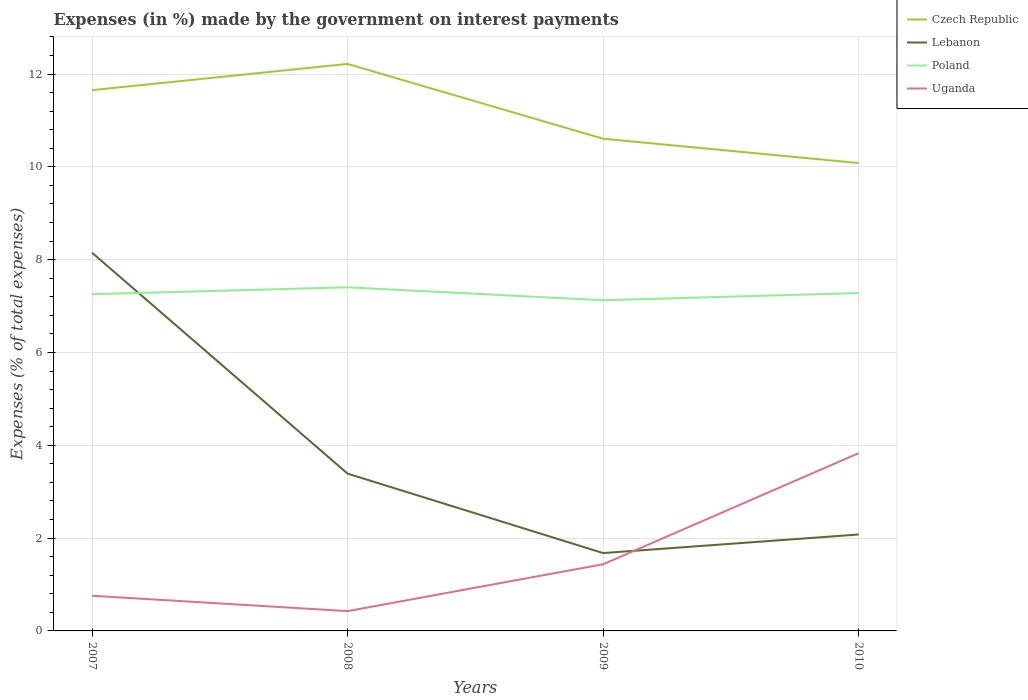How many different coloured lines are there?
Provide a short and direct response. 4. Across all years, what is the maximum percentage of expenses made by the government on interest payments in Poland?
Provide a succinct answer. 7.13. In which year was the percentage of expenses made by the government on interest payments in Uganda maximum?
Offer a very short reply. 2008. What is the total percentage of expenses made by the government on interest payments in Czech Republic in the graph?
Give a very brief answer. 1.05. What is the difference between the highest and the second highest percentage of expenses made by the government on interest payments in Lebanon?
Your response must be concise. 6.47. What is the difference between the highest and the lowest percentage of expenses made by the government on interest payments in Uganda?
Your response must be concise. 1. How many lines are there?
Make the answer very short. 4. Are the values on the major ticks of Y-axis written in scientific E-notation?
Provide a succinct answer. No. Does the graph contain any zero values?
Offer a terse response. No. Does the graph contain grids?
Your response must be concise. Yes. Where does the legend appear in the graph?
Offer a terse response. Top right. How many legend labels are there?
Make the answer very short. 4. What is the title of the graph?
Keep it short and to the point. Expenses (in %) made by the government on interest payments. Does "Portugal" appear as one of the legend labels in the graph?
Your answer should be compact. No. What is the label or title of the Y-axis?
Your answer should be compact. Expenses (% of total expenses). What is the Expenses (% of total expenses) in Czech Republic in 2007?
Your answer should be compact. 11.65. What is the Expenses (% of total expenses) in Lebanon in 2007?
Provide a succinct answer. 8.15. What is the Expenses (% of total expenses) in Poland in 2007?
Your answer should be very brief. 7.26. What is the Expenses (% of total expenses) of Uganda in 2007?
Your response must be concise. 0.76. What is the Expenses (% of total expenses) of Czech Republic in 2008?
Offer a very short reply. 12.22. What is the Expenses (% of total expenses) of Lebanon in 2008?
Keep it short and to the point. 3.39. What is the Expenses (% of total expenses) in Poland in 2008?
Give a very brief answer. 7.4. What is the Expenses (% of total expenses) in Uganda in 2008?
Give a very brief answer. 0.43. What is the Expenses (% of total expenses) in Czech Republic in 2009?
Keep it short and to the point. 10.61. What is the Expenses (% of total expenses) of Lebanon in 2009?
Give a very brief answer. 1.68. What is the Expenses (% of total expenses) of Poland in 2009?
Offer a very short reply. 7.13. What is the Expenses (% of total expenses) in Uganda in 2009?
Ensure brevity in your answer.  1.44. What is the Expenses (% of total expenses) of Czech Republic in 2010?
Your answer should be compact. 10.08. What is the Expenses (% of total expenses) in Lebanon in 2010?
Offer a very short reply. 2.08. What is the Expenses (% of total expenses) of Poland in 2010?
Provide a short and direct response. 7.28. What is the Expenses (% of total expenses) of Uganda in 2010?
Your response must be concise. 3.83. Across all years, what is the maximum Expenses (% of total expenses) of Czech Republic?
Your answer should be very brief. 12.22. Across all years, what is the maximum Expenses (% of total expenses) in Lebanon?
Make the answer very short. 8.15. Across all years, what is the maximum Expenses (% of total expenses) of Poland?
Provide a short and direct response. 7.4. Across all years, what is the maximum Expenses (% of total expenses) of Uganda?
Make the answer very short. 3.83. Across all years, what is the minimum Expenses (% of total expenses) of Czech Republic?
Keep it short and to the point. 10.08. Across all years, what is the minimum Expenses (% of total expenses) in Lebanon?
Your answer should be compact. 1.68. Across all years, what is the minimum Expenses (% of total expenses) of Poland?
Offer a very short reply. 7.13. Across all years, what is the minimum Expenses (% of total expenses) of Uganda?
Your answer should be compact. 0.43. What is the total Expenses (% of total expenses) in Czech Republic in the graph?
Your answer should be compact. 44.56. What is the total Expenses (% of total expenses) of Lebanon in the graph?
Provide a succinct answer. 15.29. What is the total Expenses (% of total expenses) in Poland in the graph?
Keep it short and to the point. 29.07. What is the total Expenses (% of total expenses) of Uganda in the graph?
Make the answer very short. 6.45. What is the difference between the Expenses (% of total expenses) in Czech Republic in 2007 and that in 2008?
Your answer should be very brief. -0.56. What is the difference between the Expenses (% of total expenses) in Lebanon in 2007 and that in 2008?
Make the answer very short. 4.76. What is the difference between the Expenses (% of total expenses) in Poland in 2007 and that in 2008?
Offer a terse response. -0.15. What is the difference between the Expenses (% of total expenses) of Uganda in 2007 and that in 2008?
Your answer should be very brief. 0.33. What is the difference between the Expenses (% of total expenses) of Czech Republic in 2007 and that in 2009?
Your response must be concise. 1.05. What is the difference between the Expenses (% of total expenses) in Lebanon in 2007 and that in 2009?
Provide a short and direct response. 6.47. What is the difference between the Expenses (% of total expenses) of Poland in 2007 and that in 2009?
Give a very brief answer. 0.13. What is the difference between the Expenses (% of total expenses) in Uganda in 2007 and that in 2009?
Your answer should be very brief. -0.68. What is the difference between the Expenses (% of total expenses) of Czech Republic in 2007 and that in 2010?
Ensure brevity in your answer.  1.57. What is the difference between the Expenses (% of total expenses) in Lebanon in 2007 and that in 2010?
Keep it short and to the point. 6.07. What is the difference between the Expenses (% of total expenses) of Poland in 2007 and that in 2010?
Give a very brief answer. -0.03. What is the difference between the Expenses (% of total expenses) in Uganda in 2007 and that in 2010?
Your answer should be compact. -3.07. What is the difference between the Expenses (% of total expenses) of Czech Republic in 2008 and that in 2009?
Offer a terse response. 1.61. What is the difference between the Expenses (% of total expenses) in Lebanon in 2008 and that in 2009?
Give a very brief answer. 1.71. What is the difference between the Expenses (% of total expenses) of Poland in 2008 and that in 2009?
Make the answer very short. 0.28. What is the difference between the Expenses (% of total expenses) in Uganda in 2008 and that in 2009?
Offer a very short reply. -1.01. What is the difference between the Expenses (% of total expenses) in Czech Republic in 2008 and that in 2010?
Give a very brief answer. 2.14. What is the difference between the Expenses (% of total expenses) in Lebanon in 2008 and that in 2010?
Ensure brevity in your answer.  1.31. What is the difference between the Expenses (% of total expenses) of Poland in 2008 and that in 2010?
Your response must be concise. 0.12. What is the difference between the Expenses (% of total expenses) in Uganda in 2008 and that in 2010?
Make the answer very short. -3.4. What is the difference between the Expenses (% of total expenses) in Czech Republic in 2009 and that in 2010?
Give a very brief answer. 0.52. What is the difference between the Expenses (% of total expenses) of Lebanon in 2009 and that in 2010?
Your answer should be very brief. -0.4. What is the difference between the Expenses (% of total expenses) of Poland in 2009 and that in 2010?
Provide a succinct answer. -0.16. What is the difference between the Expenses (% of total expenses) of Uganda in 2009 and that in 2010?
Offer a very short reply. -2.39. What is the difference between the Expenses (% of total expenses) in Czech Republic in 2007 and the Expenses (% of total expenses) in Lebanon in 2008?
Offer a very short reply. 8.26. What is the difference between the Expenses (% of total expenses) in Czech Republic in 2007 and the Expenses (% of total expenses) in Poland in 2008?
Your response must be concise. 4.25. What is the difference between the Expenses (% of total expenses) of Czech Republic in 2007 and the Expenses (% of total expenses) of Uganda in 2008?
Provide a short and direct response. 11.23. What is the difference between the Expenses (% of total expenses) of Lebanon in 2007 and the Expenses (% of total expenses) of Poland in 2008?
Offer a very short reply. 0.74. What is the difference between the Expenses (% of total expenses) in Lebanon in 2007 and the Expenses (% of total expenses) in Uganda in 2008?
Provide a short and direct response. 7.72. What is the difference between the Expenses (% of total expenses) in Poland in 2007 and the Expenses (% of total expenses) in Uganda in 2008?
Keep it short and to the point. 6.83. What is the difference between the Expenses (% of total expenses) of Czech Republic in 2007 and the Expenses (% of total expenses) of Lebanon in 2009?
Make the answer very short. 9.97. What is the difference between the Expenses (% of total expenses) of Czech Republic in 2007 and the Expenses (% of total expenses) of Poland in 2009?
Offer a very short reply. 4.53. What is the difference between the Expenses (% of total expenses) in Czech Republic in 2007 and the Expenses (% of total expenses) in Uganda in 2009?
Make the answer very short. 10.22. What is the difference between the Expenses (% of total expenses) in Lebanon in 2007 and the Expenses (% of total expenses) in Poland in 2009?
Your answer should be compact. 1.02. What is the difference between the Expenses (% of total expenses) of Lebanon in 2007 and the Expenses (% of total expenses) of Uganda in 2009?
Ensure brevity in your answer.  6.71. What is the difference between the Expenses (% of total expenses) in Poland in 2007 and the Expenses (% of total expenses) in Uganda in 2009?
Make the answer very short. 5.82. What is the difference between the Expenses (% of total expenses) of Czech Republic in 2007 and the Expenses (% of total expenses) of Lebanon in 2010?
Your response must be concise. 9.57. What is the difference between the Expenses (% of total expenses) in Czech Republic in 2007 and the Expenses (% of total expenses) in Poland in 2010?
Offer a very short reply. 4.37. What is the difference between the Expenses (% of total expenses) of Czech Republic in 2007 and the Expenses (% of total expenses) of Uganda in 2010?
Make the answer very short. 7.82. What is the difference between the Expenses (% of total expenses) in Lebanon in 2007 and the Expenses (% of total expenses) in Poland in 2010?
Your response must be concise. 0.87. What is the difference between the Expenses (% of total expenses) in Lebanon in 2007 and the Expenses (% of total expenses) in Uganda in 2010?
Your answer should be very brief. 4.32. What is the difference between the Expenses (% of total expenses) in Poland in 2007 and the Expenses (% of total expenses) in Uganda in 2010?
Give a very brief answer. 3.43. What is the difference between the Expenses (% of total expenses) of Czech Republic in 2008 and the Expenses (% of total expenses) of Lebanon in 2009?
Your response must be concise. 10.54. What is the difference between the Expenses (% of total expenses) in Czech Republic in 2008 and the Expenses (% of total expenses) in Poland in 2009?
Your answer should be compact. 5.09. What is the difference between the Expenses (% of total expenses) in Czech Republic in 2008 and the Expenses (% of total expenses) in Uganda in 2009?
Make the answer very short. 10.78. What is the difference between the Expenses (% of total expenses) of Lebanon in 2008 and the Expenses (% of total expenses) of Poland in 2009?
Provide a succinct answer. -3.74. What is the difference between the Expenses (% of total expenses) in Lebanon in 2008 and the Expenses (% of total expenses) in Uganda in 2009?
Make the answer very short. 1.95. What is the difference between the Expenses (% of total expenses) of Poland in 2008 and the Expenses (% of total expenses) of Uganda in 2009?
Provide a succinct answer. 5.97. What is the difference between the Expenses (% of total expenses) of Czech Republic in 2008 and the Expenses (% of total expenses) of Lebanon in 2010?
Your answer should be very brief. 10.14. What is the difference between the Expenses (% of total expenses) in Czech Republic in 2008 and the Expenses (% of total expenses) in Poland in 2010?
Make the answer very short. 4.94. What is the difference between the Expenses (% of total expenses) in Czech Republic in 2008 and the Expenses (% of total expenses) in Uganda in 2010?
Offer a terse response. 8.39. What is the difference between the Expenses (% of total expenses) in Lebanon in 2008 and the Expenses (% of total expenses) in Poland in 2010?
Offer a very short reply. -3.89. What is the difference between the Expenses (% of total expenses) in Lebanon in 2008 and the Expenses (% of total expenses) in Uganda in 2010?
Your response must be concise. -0.44. What is the difference between the Expenses (% of total expenses) in Poland in 2008 and the Expenses (% of total expenses) in Uganda in 2010?
Offer a terse response. 3.57. What is the difference between the Expenses (% of total expenses) in Czech Republic in 2009 and the Expenses (% of total expenses) in Lebanon in 2010?
Keep it short and to the point. 8.53. What is the difference between the Expenses (% of total expenses) of Czech Republic in 2009 and the Expenses (% of total expenses) of Poland in 2010?
Provide a succinct answer. 3.33. What is the difference between the Expenses (% of total expenses) of Czech Republic in 2009 and the Expenses (% of total expenses) of Uganda in 2010?
Ensure brevity in your answer.  6.78. What is the difference between the Expenses (% of total expenses) in Lebanon in 2009 and the Expenses (% of total expenses) in Poland in 2010?
Your answer should be very brief. -5.6. What is the difference between the Expenses (% of total expenses) of Lebanon in 2009 and the Expenses (% of total expenses) of Uganda in 2010?
Keep it short and to the point. -2.15. What is the difference between the Expenses (% of total expenses) of Poland in 2009 and the Expenses (% of total expenses) of Uganda in 2010?
Give a very brief answer. 3.3. What is the average Expenses (% of total expenses) of Czech Republic per year?
Offer a terse response. 11.14. What is the average Expenses (% of total expenses) in Lebanon per year?
Offer a very short reply. 3.82. What is the average Expenses (% of total expenses) in Poland per year?
Provide a succinct answer. 7.27. What is the average Expenses (% of total expenses) in Uganda per year?
Provide a succinct answer. 1.61. In the year 2007, what is the difference between the Expenses (% of total expenses) of Czech Republic and Expenses (% of total expenses) of Lebanon?
Ensure brevity in your answer.  3.5. In the year 2007, what is the difference between the Expenses (% of total expenses) in Czech Republic and Expenses (% of total expenses) in Poland?
Make the answer very short. 4.4. In the year 2007, what is the difference between the Expenses (% of total expenses) of Czech Republic and Expenses (% of total expenses) of Uganda?
Your response must be concise. 10.89. In the year 2007, what is the difference between the Expenses (% of total expenses) of Lebanon and Expenses (% of total expenses) of Poland?
Keep it short and to the point. 0.89. In the year 2007, what is the difference between the Expenses (% of total expenses) of Lebanon and Expenses (% of total expenses) of Uganda?
Make the answer very short. 7.39. In the year 2007, what is the difference between the Expenses (% of total expenses) of Poland and Expenses (% of total expenses) of Uganda?
Keep it short and to the point. 6.5. In the year 2008, what is the difference between the Expenses (% of total expenses) in Czech Republic and Expenses (% of total expenses) in Lebanon?
Offer a terse response. 8.83. In the year 2008, what is the difference between the Expenses (% of total expenses) in Czech Republic and Expenses (% of total expenses) in Poland?
Make the answer very short. 4.81. In the year 2008, what is the difference between the Expenses (% of total expenses) in Czech Republic and Expenses (% of total expenses) in Uganda?
Offer a very short reply. 11.79. In the year 2008, what is the difference between the Expenses (% of total expenses) in Lebanon and Expenses (% of total expenses) in Poland?
Offer a terse response. -4.01. In the year 2008, what is the difference between the Expenses (% of total expenses) in Lebanon and Expenses (% of total expenses) in Uganda?
Make the answer very short. 2.96. In the year 2008, what is the difference between the Expenses (% of total expenses) of Poland and Expenses (% of total expenses) of Uganda?
Make the answer very short. 6.98. In the year 2009, what is the difference between the Expenses (% of total expenses) in Czech Republic and Expenses (% of total expenses) in Lebanon?
Offer a terse response. 8.93. In the year 2009, what is the difference between the Expenses (% of total expenses) in Czech Republic and Expenses (% of total expenses) in Poland?
Your answer should be very brief. 3.48. In the year 2009, what is the difference between the Expenses (% of total expenses) in Czech Republic and Expenses (% of total expenses) in Uganda?
Offer a terse response. 9.17. In the year 2009, what is the difference between the Expenses (% of total expenses) of Lebanon and Expenses (% of total expenses) of Poland?
Ensure brevity in your answer.  -5.45. In the year 2009, what is the difference between the Expenses (% of total expenses) in Lebanon and Expenses (% of total expenses) in Uganda?
Make the answer very short. 0.24. In the year 2009, what is the difference between the Expenses (% of total expenses) in Poland and Expenses (% of total expenses) in Uganda?
Your answer should be very brief. 5.69. In the year 2010, what is the difference between the Expenses (% of total expenses) in Czech Republic and Expenses (% of total expenses) in Lebanon?
Provide a succinct answer. 8. In the year 2010, what is the difference between the Expenses (% of total expenses) of Czech Republic and Expenses (% of total expenses) of Poland?
Offer a very short reply. 2.8. In the year 2010, what is the difference between the Expenses (% of total expenses) in Czech Republic and Expenses (% of total expenses) in Uganda?
Keep it short and to the point. 6.25. In the year 2010, what is the difference between the Expenses (% of total expenses) of Lebanon and Expenses (% of total expenses) of Poland?
Provide a succinct answer. -5.2. In the year 2010, what is the difference between the Expenses (% of total expenses) of Lebanon and Expenses (% of total expenses) of Uganda?
Your answer should be compact. -1.75. In the year 2010, what is the difference between the Expenses (% of total expenses) of Poland and Expenses (% of total expenses) of Uganda?
Your answer should be very brief. 3.45. What is the ratio of the Expenses (% of total expenses) of Czech Republic in 2007 to that in 2008?
Your answer should be very brief. 0.95. What is the ratio of the Expenses (% of total expenses) of Lebanon in 2007 to that in 2008?
Keep it short and to the point. 2.4. What is the ratio of the Expenses (% of total expenses) in Poland in 2007 to that in 2008?
Offer a terse response. 0.98. What is the ratio of the Expenses (% of total expenses) in Uganda in 2007 to that in 2008?
Your response must be concise. 1.78. What is the ratio of the Expenses (% of total expenses) of Czech Republic in 2007 to that in 2009?
Give a very brief answer. 1.1. What is the ratio of the Expenses (% of total expenses) of Lebanon in 2007 to that in 2009?
Provide a short and direct response. 4.86. What is the ratio of the Expenses (% of total expenses) in Poland in 2007 to that in 2009?
Give a very brief answer. 1.02. What is the ratio of the Expenses (% of total expenses) in Uganda in 2007 to that in 2009?
Make the answer very short. 0.53. What is the ratio of the Expenses (% of total expenses) of Czech Republic in 2007 to that in 2010?
Ensure brevity in your answer.  1.16. What is the ratio of the Expenses (% of total expenses) in Lebanon in 2007 to that in 2010?
Provide a succinct answer. 3.92. What is the ratio of the Expenses (% of total expenses) in Poland in 2007 to that in 2010?
Ensure brevity in your answer.  1. What is the ratio of the Expenses (% of total expenses) in Uganda in 2007 to that in 2010?
Make the answer very short. 0.2. What is the ratio of the Expenses (% of total expenses) of Czech Republic in 2008 to that in 2009?
Ensure brevity in your answer.  1.15. What is the ratio of the Expenses (% of total expenses) in Lebanon in 2008 to that in 2009?
Your answer should be compact. 2.02. What is the ratio of the Expenses (% of total expenses) in Poland in 2008 to that in 2009?
Provide a succinct answer. 1.04. What is the ratio of the Expenses (% of total expenses) of Uganda in 2008 to that in 2009?
Ensure brevity in your answer.  0.3. What is the ratio of the Expenses (% of total expenses) in Czech Republic in 2008 to that in 2010?
Ensure brevity in your answer.  1.21. What is the ratio of the Expenses (% of total expenses) of Lebanon in 2008 to that in 2010?
Provide a succinct answer. 1.63. What is the ratio of the Expenses (% of total expenses) in Poland in 2008 to that in 2010?
Offer a terse response. 1.02. What is the ratio of the Expenses (% of total expenses) of Uganda in 2008 to that in 2010?
Provide a succinct answer. 0.11. What is the ratio of the Expenses (% of total expenses) of Czech Republic in 2009 to that in 2010?
Offer a very short reply. 1.05. What is the ratio of the Expenses (% of total expenses) of Lebanon in 2009 to that in 2010?
Provide a succinct answer. 0.81. What is the ratio of the Expenses (% of total expenses) of Poland in 2009 to that in 2010?
Your answer should be very brief. 0.98. What is the ratio of the Expenses (% of total expenses) in Uganda in 2009 to that in 2010?
Offer a terse response. 0.38. What is the difference between the highest and the second highest Expenses (% of total expenses) of Czech Republic?
Give a very brief answer. 0.56. What is the difference between the highest and the second highest Expenses (% of total expenses) in Lebanon?
Keep it short and to the point. 4.76. What is the difference between the highest and the second highest Expenses (% of total expenses) in Poland?
Offer a very short reply. 0.12. What is the difference between the highest and the second highest Expenses (% of total expenses) in Uganda?
Make the answer very short. 2.39. What is the difference between the highest and the lowest Expenses (% of total expenses) in Czech Republic?
Your response must be concise. 2.14. What is the difference between the highest and the lowest Expenses (% of total expenses) of Lebanon?
Give a very brief answer. 6.47. What is the difference between the highest and the lowest Expenses (% of total expenses) in Poland?
Offer a terse response. 0.28. What is the difference between the highest and the lowest Expenses (% of total expenses) in Uganda?
Make the answer very short. 3.4. 